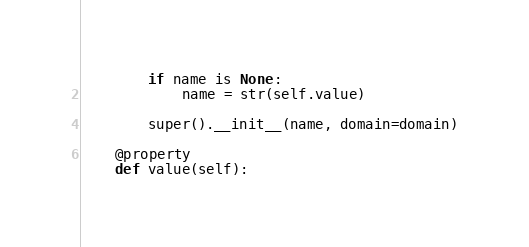<code> <loc_0><loc_0><loc_500><loc_500><_Python_>        if name is None:
            name = str(self.value)

        super().__init__(name, domain=domain)

    @property
    def value(self):</code> 